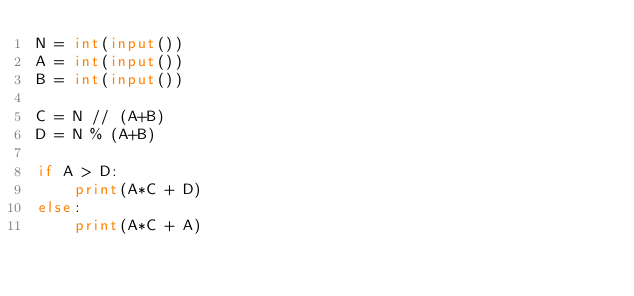<code> <loc_0><loc_0><loc_500><loc_500><_Python_>N = int(input())
A = int(input())
B = int(input())

C = N // (A+B)
D = N % (A+B)

if A > D:
    print(A*C + D)
else:
    print(A*C + A)


    </code> 